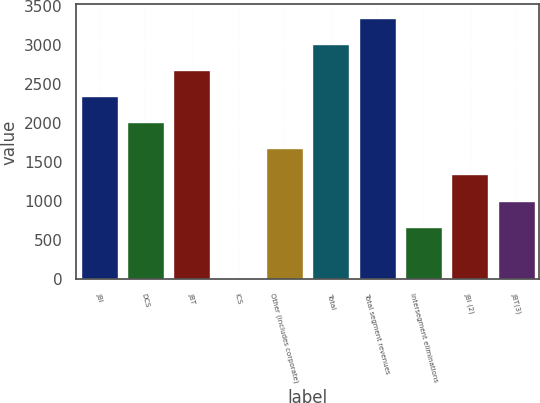<chart> <loc_0><loc_0><loc_500><loc_500><bar_chart><fcel>JBI<fcel>DCS<fcel>JBT<fcel>ICS<fcel>Other (includes corporate)<fcel>Total<fcel>Total segment revenues<fcel>Intersegment eliminations<fcel>JBI (2)<fcel>JBT(3)<nl><fcel>2348.3<fcel>2013.4<fcel>2683.2<fcel>4<fcel>1678.5<fcel>3018.1<fcel>3353<fcel>673.8<fcel>1343.6<fcel>1008.7<nl></chart> 